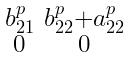<formula> <loc_0><loc_0><loc_500><loc_500>\begin{smallmatrix} b _ { 2 1 } ^ { p } & b _ { 2 2 } ^ { p } + a _ { 2 2 } ^ { p } \\ 0 & 0 \end{smallmatrix}</formula> 